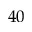<formula> <loc_0><loc_0><loc_500><loc_500>4 0</formula> 